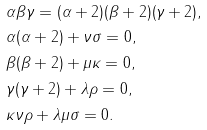<formula> <loc_0><loc_0><loc_500><loc_500>& \alpha \beta \gamma = ( \alpha + 2 ) ( \beta + 2 ) ( \gamma + 2 ) , \\ & \alpha ( \alpha + 2 ) + \nu \sigma = 0 , \\ & \beta ( \beta + 2 ) + \mu \kappa = 0 , \\ & \gamma ( \gamma + 2 ) + \lambda \rho = 0 , \\ & \kappa \nu \rho + \lambda \mu \sigma = 0 .</formula> 